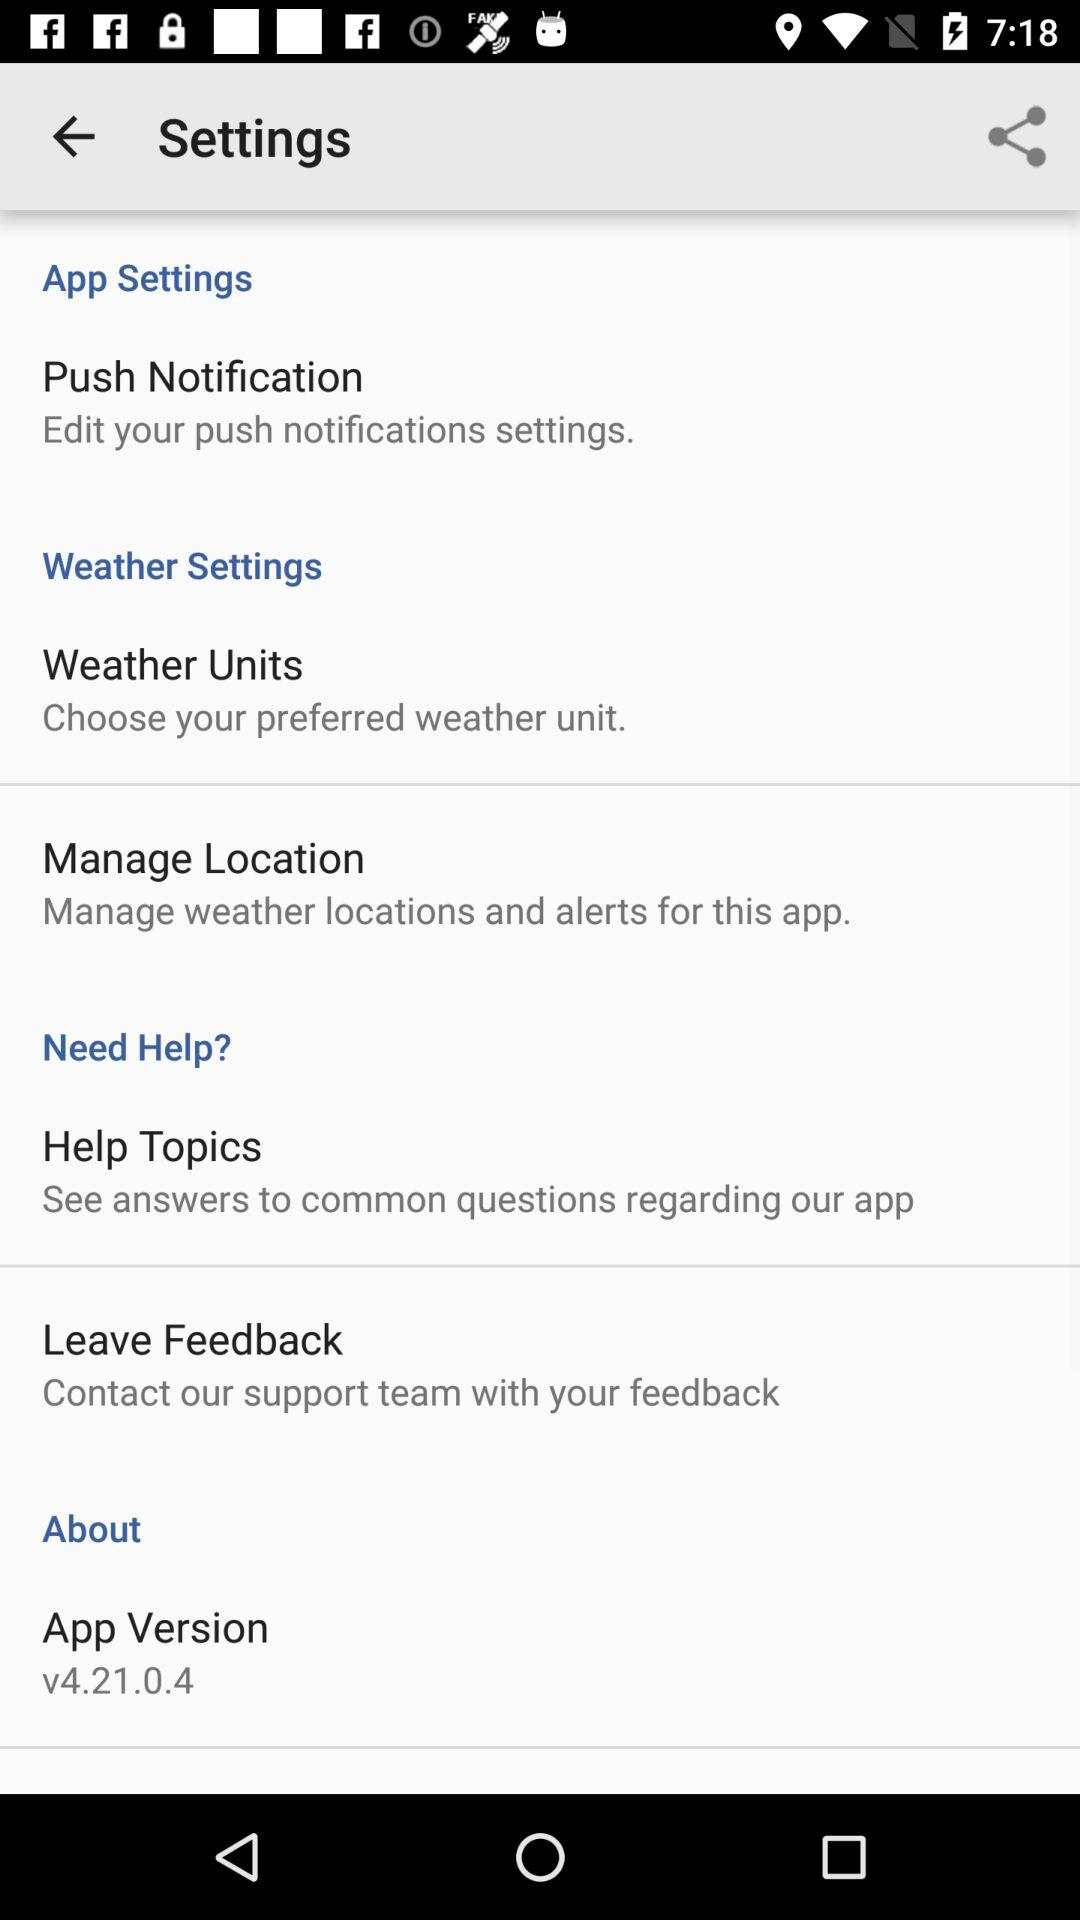What is the app version? The app version is v4.21.0.4. 